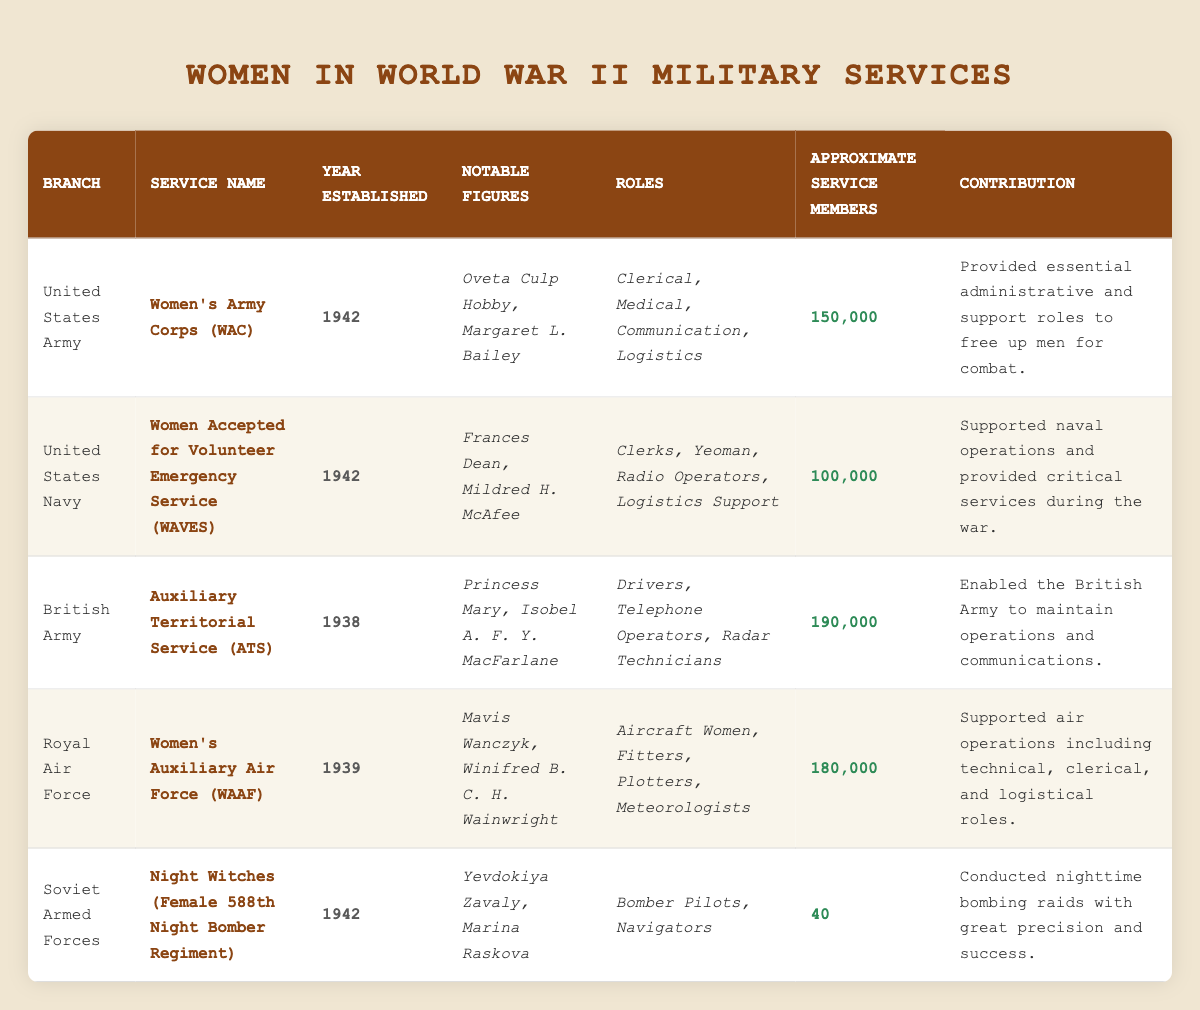What is the approximate number of service members in the Women's Army Corps (WAC)? The table lists the approximate service members for the WAC under the "Approximate Service Members" column, which shows the value as 150,000.
Answer: 150,000 Which military branch had the largest number of service members? By comparing the "Approximate Service Members" values: WAC (150,000), WAVES (100,000), ATS (190,000), WAAF (180,000), and Night Witches (40), the British Army's Auxiliary Territorial Service (ATS) has the largest number at 190,000.
Answer: British Army Did the Women's Auxiliary Air Force (WAAF) get established before 1940? The "Year Established" for WAAF is 1939, indicating that it was established before 1940.
Answer: Yes How many more service members were there in the Auxiliary Territorial Service (ATS) than in the Night Witches? The ATS had 190,000 service members, and the Night Witches had 40. To find the difference, subtract 40 from 190,000: 190,000 - 40 = 189,960.
Answer: 189,960 Which service branch was established in 1942 and had notable figures? Both the Women's Army Corps (WAC) and the Women Accepted for Volunteer Emergency Service (WAVES) were established in 1942 and have notable figures listed.
Answer: WAC and WAVES What percentage of the combined total service members for the WAC and WAVES were from the WAC? First, calculate the total for WAC and WAVES: 150,000 (WAC) + 100,000 (WAVES) = 250,000. Then, to find the percentage, divide the WAC members by the total: (150,000 / 250,000) * 100 = 60%.
Answer: 60% How many roles were listed for the Women's Army Corps (WAC)? The table specifies the roles under the WAC as: Clerical, Medical, Communication, and Logistics. This totals to 4 distinct roles.
Answer: 4 What is the earliest established service branch among the ones listed? The ATS was established in 1938, which is earlier than the WAC and WAVES (both 1942) and WAAF (1939). Thus, it is the earliest.
Answer: Auxiliary Territorial Service (ATS) Did any military branch have female pilots? The data indicates that the Night Witches (Female 588th Night Bomber Regiment) had bomber pilots as part of their roles, confirming that they did have female pilots.
Answer: Yes How many service members did the Royal Air Force (WAAF) have, and how does it compare to the Soviet Armed Forces' Night Witches? The WAAF had 180,000 members while the Night Witches only had 40. Comparing these shows the WAAF had significantly more: 180,000 - 40 = 179,960 more members.
Answer: WAAF had 179,960 more members 